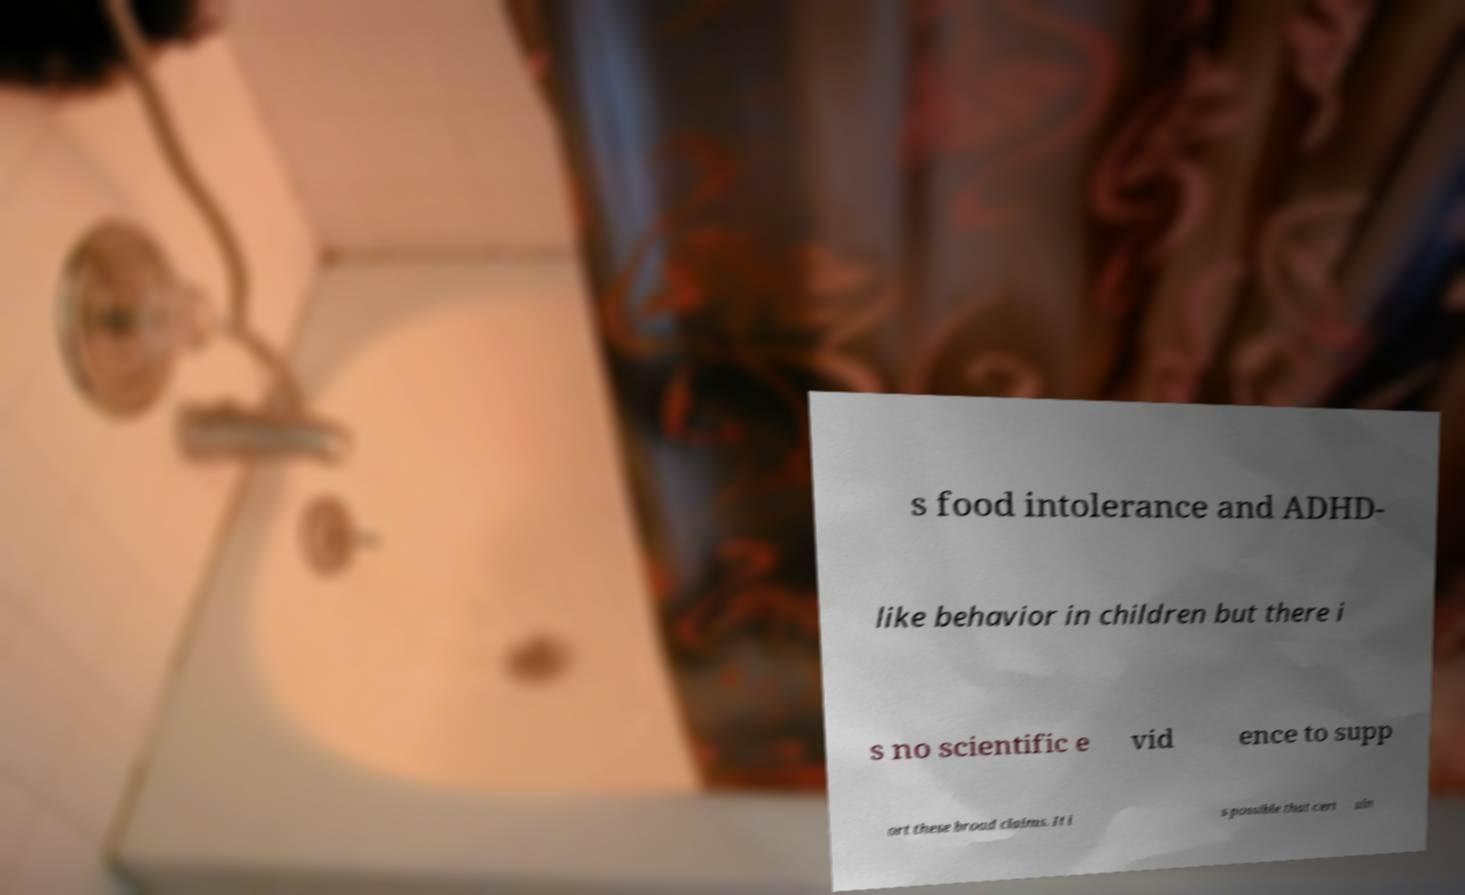Please identify and transcribe the text found in this image. s food intolerance and ADHD- like behavior in children but there i s no scientific e vid ence to supp ort these broad claims. It i s possible that cert ain 